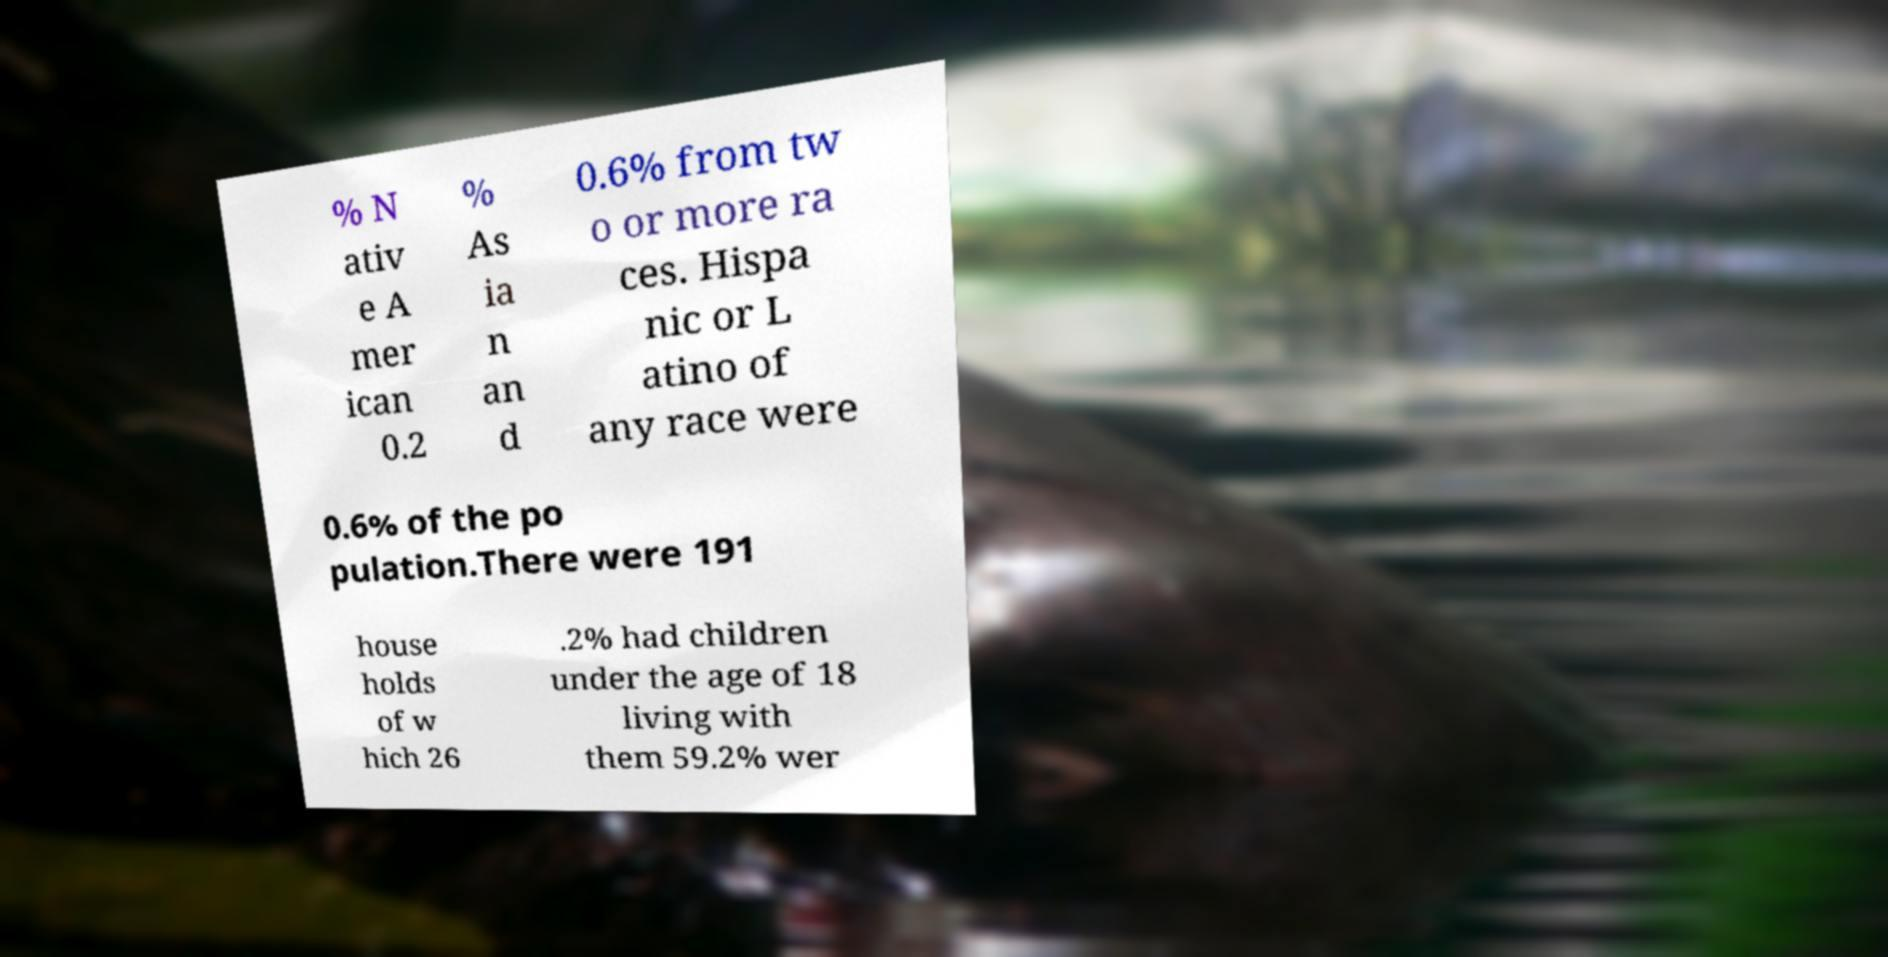Can you read and provide the text displayed in the image?This photo seems to have some interesting text. Can you extract and type it out for me? % N ativ e A mer ican 0.2 % As ia n an d 0.6% from tw o or more ra ces. Hispa nic or L atino of any race were 0.6% of the po pulation.There were 191 house holds of w hich 26 .2% had children under the age of 18 living with them 59.2% wer 